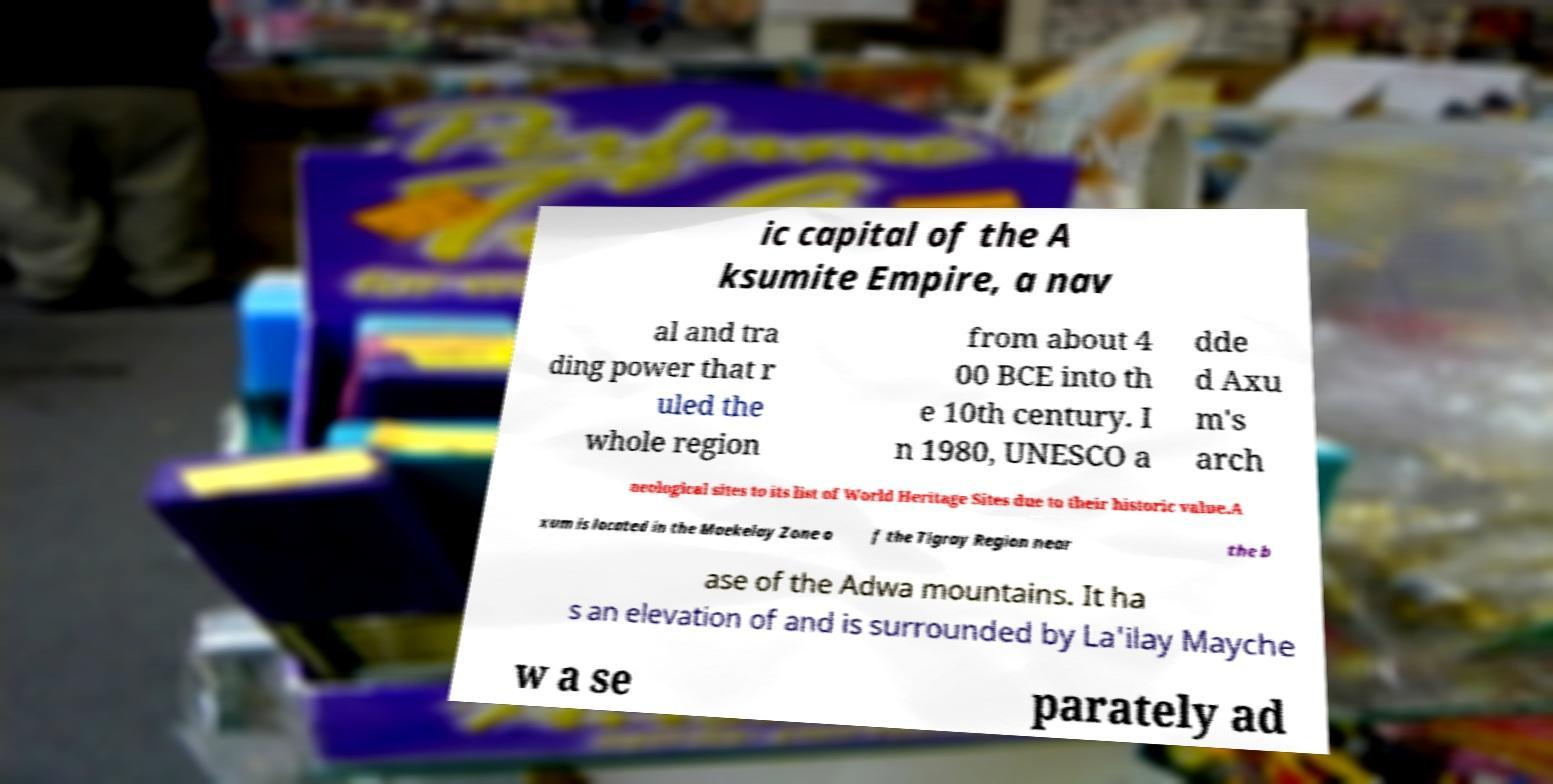Could you assist in decoding the text presented in this image and type it out clearly? ic capital of the A ksumite Empire, a nav al and tra ding power that r uled the whole region from about 4 00 BCE into th e 10th century. I n 1980, UNESCO a dde d Axu m's arch aeological sites to its list of World Heritage Sites due to their historic value.A xum is located in the Maekelay Zone o f the Tigray Region near the b ase of the Adwa mountains. It ha s an elevation of and is surrounded by La'ilay Mayche w a se parately ad 